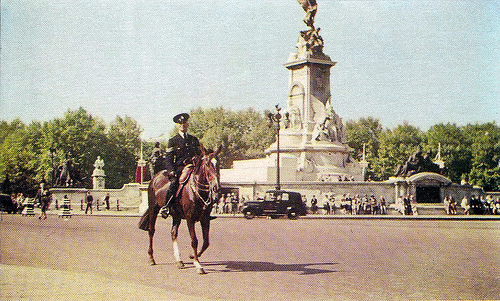How many people are running near horse? 0 